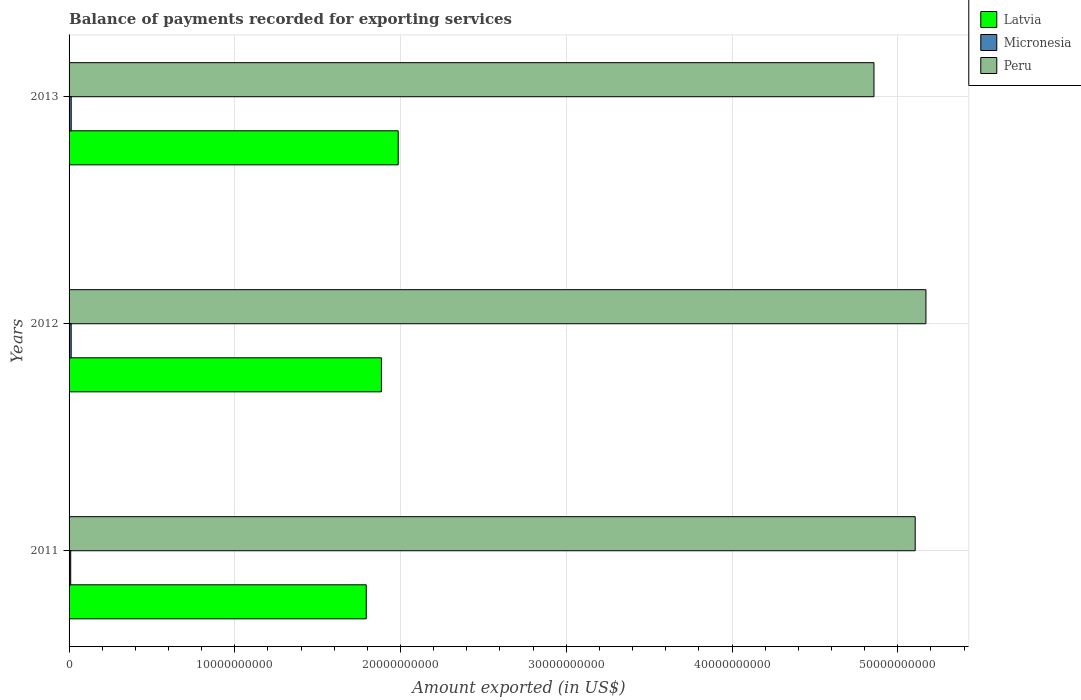How many different coloured bars are there?
Keep it short and to the point. 3. Are the number of bars on each tick of the Y-axis equal?
Your response must be concise. Yes. How many bars are there on the 2nd tick from the top?
Ensure brevity in your answer.  3. How many bars are there on the 3rd tick from the bottom?
Give a very brief answer. 3. What is the label of the 3rd group of bars from the top?
Provide a succinct answer. 2011. In how many cases, is the number of bars for a given year not equal to the number of legend labels?
Your answer should be compact. 0. What is the amount exported in Micronesia in 2013?
Your answer should be compact. 1.28e+08. Across all years, what is the maximum amount exported in Latvia?
Make the answer very short. 1.99e+1. Across all years, what is the minimum amount exported in Peru?
Your response must be concise. 4.86e+1. In which year was the amount exported in Peru maximum?
Provide a succinct answer. 2012. In which year was the amount exported in Peru minimum?
Make the answer very short. 2013. What is the total amount exported in Micronesia in the graph?
Offer a terse response. 3.54e+08. What is the difference between the amount exported in Latvia in 2011 and that in 2013?
Give a very brief answer. -1.93e+09. What is the difference between the amount exported in Peru in 2011 and the amount exported in Micronesia in 2012?
Provide a short and direct response. 5.09e+1. What is the average amount exported in Latvia per year?
Provide a short and direct response. 1.89e+1. In the year 2011, what is the difference between the amount exported in Latvia and amount exported in Peru?
Offer a terse response. -3.31e+1. What is the ratio of the amount exported in Micronesia in 2011 to that in 2013?
Your answer should be compact. 0.77. Is the amount exported in Micronesia in 2011 less than that in 2013?
Offer a very short reply. Yes. What is the difference between the highest and the second highest amount exported in Micronesia?
Your response must be concise. 1.06e+06. What is the difference between the highest and the lowest amount exported in Latvia?
Provide a succinct answer. 1.93e+09. In how many years, is the amount exported in Micronesia greater than the average amount exported in Micronesia taken over all years?
Provide a short and direct response. 2. Is the sum of the amount exported in Micronesia in 2012 and 2013 greater than the maximum amount exported in Peru across all years?
Make the answer very short. No. What does the 3rd bar from the top in 2011 represents?
Your response must be concise. Latvia. What does the 2nd bar from the bottom in 2013 represents?
Your answer should be very brief. Micronesia. How many bars are there?
Provide a succinct answer. 9. How many years are there in the graph?
Give a very brief answer. 3. Does the graph contain grids?
Make the answer very short. Yes. How many legend labels are there?
Make the answer very short. 3. How are the legend labels stacked?
Give a very brief answer. Vertical. What is the title of the graph?
Your response must be concise. Balance of payments recorded for exporting services. What is the label or title of the X-axis?
Provide a succinct answer. Amount exported (in US$). What is the label or title of the Y-axis?
Make the answer very short. Years. What is the Amount exported (in US$) in Latvia in 2011?
Keep it short and to the point. 1.79e+1. What is the Amount exported (in US$) in Micronesia in 2011?
Your answer should be compact. 9.91e+07. What is the Amount exported (in US$) in Peru in 2011?
Give a very brief answer. 5.11e+1. What is the Amount exported (in US$) of Latvia in 2012?
Your answer should be compact. 1.88e+1. What is the Amount exported (in US$) of Micronesia in 2012?
Ensure brevity in your answer.  1.27e+08. What is the Amount exported (in US$) of Peru in 2012?
Provide a succinct answer. 5.17e+1. What is the Amount exported (in US$) of Latvia in 2013?
Ensure brevity in your answer.  1.99e+1. What is the Amount exported (in US$) of Micronesia in 2013?
Ensure brevity in your answer.  1.28e+08. What is the Amount exported (in US$) in Peru in 2013?
Your answer should be very brief. 4.86e+1. Across all years, what is the maximum Amount exported (in US$) in Latvia?
Provide a short and direct response. 1.99e+1. Across all years, what is the maximum Amount exported (in US$) in Micronesia?
Your answer should be compact. 1.28e+08. Across all years, what is the maximum Amount exported (in US$) in Peru?
Make the answer very short. 5.17e+1. Across all years, what is the minimum Amount exported (in US$) of Latvia?
Ensure brevity in your answer.  1.79e+1. Across all years, what is the minimum Amount exported (in US$) in Micronesia?
Your response must be concise. 9.91e+07. Across all years, what is the minimum Amount exported (in US$) of Peru?
Your answer should be very brief. 4.86e+1. What is the total Amount exported (in US$) of Latvia in the graph?
Make the answer very short. 5.66e+1. What is the total Amount exported (in US$) of Micronesia in the graph?
Your answer should be compact. 3.54e+08. What is the total Amount exported (in US$) of Peru in the graph?
Provide a short and direct response. 1.51e+11. What is the difference between the Amount exported (in US$) of Latvia in 2011 and that in 2012?
Offer a very short reply. -9.16e+08. What is the difference between the Amount exported (in US$) in Micronesia in 2011 and that in 2012?
Give a very brief answer. -2.81e+07. What is the difference between the Amount exported (in US$) in Peru in 2011 and that in 2012?
Make the answer very short. -6.47e+08. What is the difference between the Amount exported (in US$) in Latvia in 2011 and that in 2013?
Your response must be concise. -1.93e+09. What is the difference between the Amount exported (in US$) of Micronesia in 2011 and that in 2013?
Your answer should be compact. -2.91e+07. What is the difference between the Amount exported (in US$) of Peru in 2011 and that in 2013?
Provide a short and direct response. 2.49e+09. What is the difference between the Amount exported (in US$) of Latvia in 2012 and that in 2013?
Your answer should be very brief. -1.01e+09. What is the difference between the Amount exported (in US$) of Micronesia in 2012 and that in 2013?
Offer a terse response. -1.06e+06. What is the difference between the Amount exported (in US$) in Peru in 2012 and that in 2013?
Keep it short and to the point. 3.13e+09. What is the difference between the Amount exported (in US$) in Latvia in 2011 and the Amount exported (in US$) in Micronesia in 2012?
Offer a terse response. 1.78e+1. What is the difference between the Amount exported (in US$) of Latvia in 2011 and the Amount exported (in US$) of Peru in 2012?
Ensure brevity in your answer.  -3.38e+1. What is the difference between the Amount exported (in US$) of Micronesia in 2011 and the Amount exported (in US$) of Peru in 2012?
Your answer should be very brief. -5.16e+1. What is the difference between the Amount exported (in US$) of Latvia in 2011 and the Amount exported (in US$) of Micronesia in 2013?
Your answer should be compact. 1.78e+1. What is the difference between the Amount exported (in US$) in Latvia in 2011 and the Amount exported (in US$) in Peru in 2013?
Ensure brevity in your answer.  -3.06e+1. What is the difference between the Amount exported (in US$) of Micronesia in 2011 and the Amount exported (in US$) of Peru in 2013?
Offer a very short reply. -4.85e+1. What is the difference between the Amount exported (in US$) in Latvia in 2012 and the Amount exported (in US$) in Micronesia in 2013?
Your response must be concise. 1.87e+1. What is the difference between the Amount exported (in US$) in Latvia in 2012 and the Amount exported (in US$) in Peru in 2013?
Provide a short and direct response. -2.97e+1. What is the difference between the Amount exported (in US$) of Micronesia in 2012 and the Amount exported (in US$) of Peru in 2013?
Offer a very short reply. -4.84e+1. What is the average Amount exported (in US$) in Latvia per year?
Give a very brief answer. 1.89e+1. What is the average Amount exported (in US$) of Micronesia per year?
Offer a very short reply. 1.18e+08. What is the average Amount exported (in US$) of Peru per year?
Your response must be concise. 5.04e+1. In the year 2011, what is the difference between the Amount exported (in US$) in Latvia and Amount exported (in US$) in Micronesia?
Keep it short and to the point. 1.78e+1. In the year 2011, what is the difference between the Amount exported (in US$) of Latvia and Amount exported (in US$) of Peru?
Your response must be concise. -3.31e+1. In the year 2011, what is the difference between the Amount exported (in US$) of Micronesia and Amount exported (in US$) of Peru?
Ensure brevity in your answer.  -5.10e+1. In the year 2012, what is the difference between the Amount exported (in US$) in Latvia and Amount exported (in US$) in Micronesia?
Ensure brevity in your answer.  1.87e+1. In the year 2012, what is the difference between the Amount exported (in US$) in Latvia and Amount exported (in US$) in Peru?
Offer a terse response. -3.29e+1. In the year 2012, what is the difference between the Amount exported (in US$) of Micronesia and Amount exported (in US$) of Peru?
Offer a terse response. -5.16e+1. In the year 2013, what is the difference between the Amount exported (in US$) in Latvia and Amount exported (in US$) in Micronesia?
Make the answer very short. 1.97e+1. In the year 2013, what is the difference between the Amount exported (in US$) of Latvia and Amount exported (in US$) of Peru?
Your response must be concise. -2.87e+1. In the year 2013, what is the difference between the Amount exported (in US$) in Micronesia and Amount exported (in US$) in Peru?
Make the answer very short. -4.84e+1. What is the ratio of the Amount exported (in US$) in Latvia in 2011 to that in 2012?
Provide a short and direct response. 0.95. What is the ratio of the Amount exported (in US$) in Micronesia in 2011 to that in 2012?
Your response must be concise. 0.78. What is the ratio of the Amount exported (in US$) of Peru in 2011 to that in 2012?
Make the answer very short. 0.99. What is the ratio of the Amount exported (in US$) of Latvia in 2011 to that in 2013?
Ensure brevity in your answer.  0.9. What is the ratio of the Amount exported (in US$) in Micronesia in 2011 to that in 2013?
Make the answer very short. 0.77. What is the ratio of the Amount exported (in US$) in Peru in 2011 to that in 2013?
Keep it short and to the point. 1.05. What is the ratio of the Amount exported (in US$) in Latvia in 2012 to that in 2013?
Offer a terse response. 0.95. What is the ratio of the Amount exported (in US$) of Micronesia in 2012 to that in 2013?
Provide a short and direct response. 0.99. What is the ratio of the Amount exported (in US$) in Peru in 2012 to that in 2013?
Your answer should be compact. 1.06. What is the difference between the highest and the second highest Amount exported (in US$) in Latvia?
Offer a very short reply. 1.01e+09. What is the difference between the highest and the second highest Amount exported (in US$) in Micronesia?
Your answer should be compact. 1.06e+06. What is the difference between the highest and the second highest Amount exported (in US$) in Peru?
Make the answer very short. 6.47e+08. What is the difference between the highest and the lowest Amount exported (in US$) in Latvia?
Provide a succinct answer. 1.93e+09. What is the difference between the highest and the lowest Amount exported (in US$) in Micronesia?
Make the answer very short. 2.91e+07. What is the difference between the highest and the lowest Amount exported (in US$) of Peru?
Offer a very short reply. 3.13e+09. 